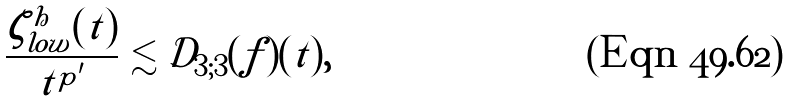<formula> <loc_0><loc_0><loc_500><loc_500>\frac { \zeta ^ { h } _ { l o w } ( t ) } { t ^ { p ^ { \prime } } } \lesssim \tilde { \mathcal { D } } _ { 3 ; 3 } ( f ) ( t ) ,</formula> 